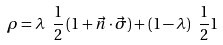Convert formula to latex. <formula><loc_0><loc_0><loc_500><loc_500>\rho = \lambda \ \frac { 1 } { 2 } \left ( { 1 } + \vec { n } \cdot \vec { \sigma } \right ) + ( 1 - \lambda ) \ \frac { 1 } { 2 } { 1 }</formula> 